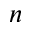Convert formula to latex. <formula><loc_0><loc_0><loc_500><loc_500>n</formula> 